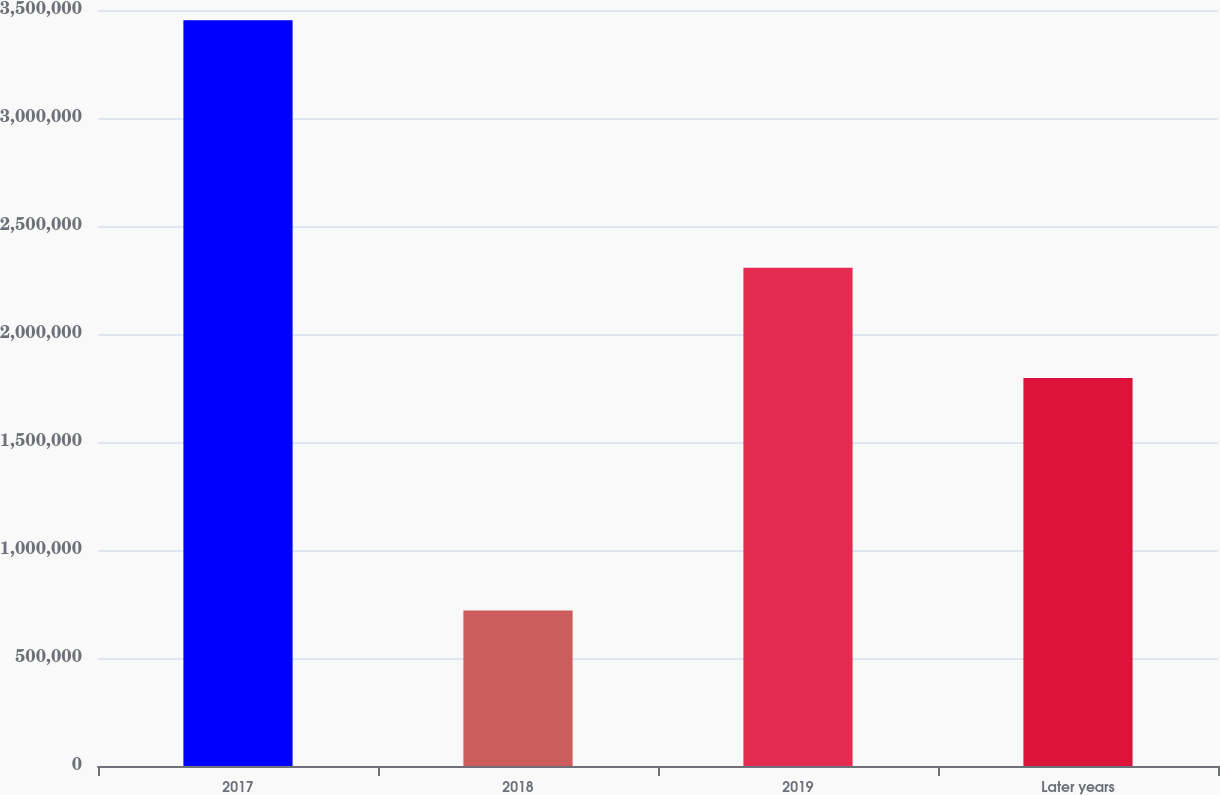Convert chart to OTSL. <chart><loc_0><loc_0><loc_500><loc_500><bar_chart><fcel>2017<fcel>2018<fcel>2019<fcel>Later years<nl><fcel>3.45242e+06<fcel>719574<fcel>2.30633e+06<fcel>1.79636e+06<nl></chart> 